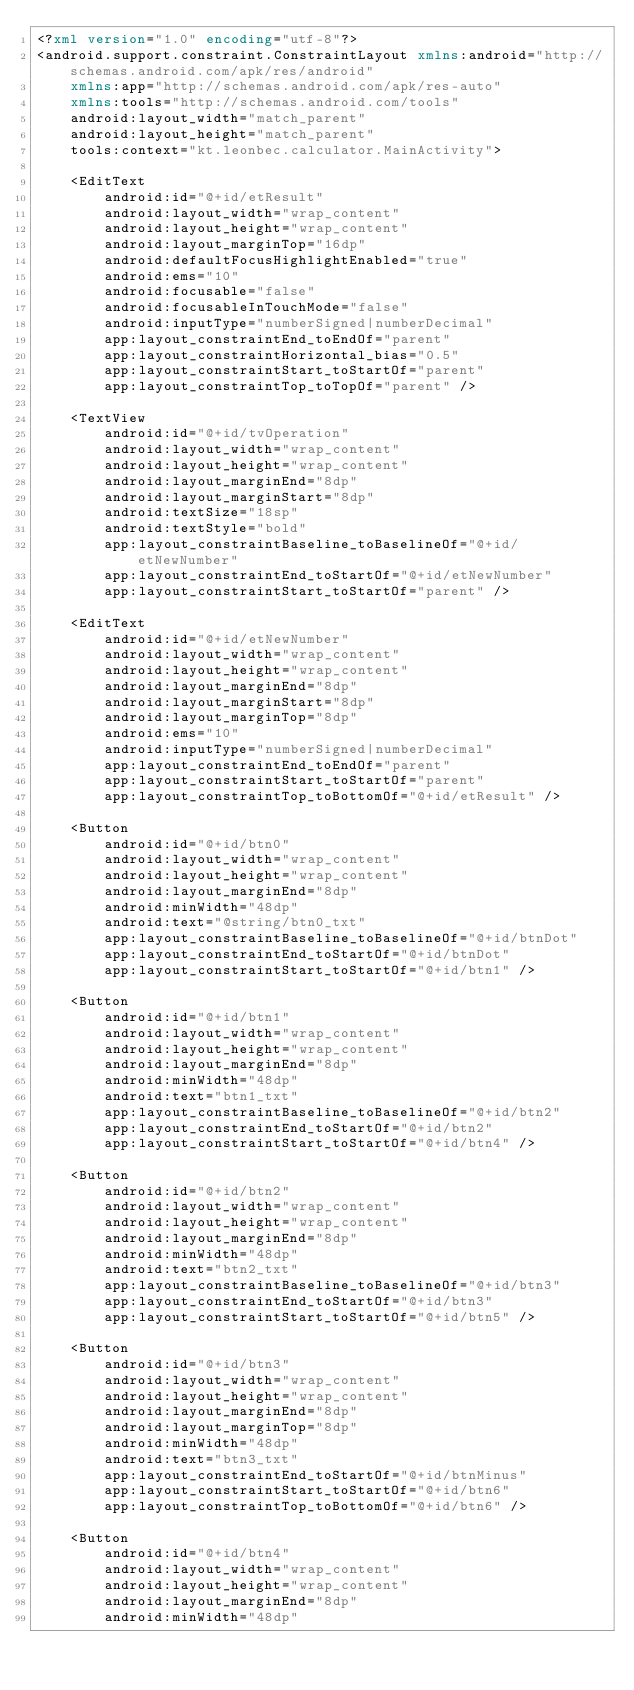Convert code to text. <code><loc_0><loc_0><loc_500><loc_500><_XML_><?xml version="1.0" encoding="utf-8"?>
<android.support.constraint.ConstraintLayout xmlns:android="http://schemas.android.com/apk/res/android"
    xmlns:app="http://schemas.android.com/apk/res-auto"
    xmlns:tools="http://schemas.android.com/tools"
    android:layout_width="match_parent"
    android:layout_height="match_parent"
    tools:context="kt.leonbec.calculator.MainActivity">

    <EditText
        android:id="@+id/etResult"
        android:layout_width="wrap_content"
        android:layout_height="wrap_content"
        android:layout_marginTop="16dp"
        android:defaultFocusHighlightEnabled="true"
        android:ems="10"
        android:focusable="false"
        android:focusableInTouchMode="false"
        android:inputType="numberSigned|numberDecimal"
        app:layout_constraintEnd_toEndOf="parent"
        app:layout_constraintHorizontal_bias="0.5"
        app:layout_constraintStart_toStartOf="parent"
        app:layout_constraintTop_toTopOf="parent" />

    <TextView
        android:id="@+id/tvOperation"
        android:layout_width="wrap_content"
        android:layout_height="wrap_content"
        android:layout_marginEnd="8dp"
        android:layout_marginStart="8dp"
        android:textSize="18sp"
        android:textStyle="bold"
        app:layout_constraintBaseline_toBaselineOf="@+id/etNewNumber"
        app:layout_constraintEnd_toStartOf="@+id/etNewNumber"
        app:layout_constraintStart_toStartOf="parent" />

    <EditText
        android:id="@+id/etNewNumber"
        android:layout_width="wrap_content"
        android:layout_height="wrap_content"
        android:layout_marginEnd="8dp"
        android:layout_marginStart="8dp"
        android:layout_marginTop="8dp"
        android:ems="10"
        android:inputType="numberSigned|numberDecimal"
        app:layout_constraintEnd_toEndOf="parent"
        app:layout_constraintStart_toStartOf="parent"
        app:layout_constraintTop_toBottomOf="@+id/etResult" />

    <Button
        android:id="@+id/btn0"
        android:layout_width="wrap_content"
        android:layout_height="wrap_content"
        android:layout_marginEnd="8dp"
        android:minWidth="48dp"
        android:text="@string/btn0_txt"
        app:layout_constraintBaseline_toBaselineOf="@+id/btnDot"
        app:layout_constraintEnd_toStartOf="@+id/btnDot"
        app:layout_constraintStart_toStartOf="@+id/btn1" />

    <Button
        android:id="@+id/btn1"
        android:layout_width="wrap_content"
        android:layout_height="wrap_content"
        android:layout_marginEnd="8dp"
        android:minWidth="48dp"
        android:text="btn1_txt"
        app:layout_constraintBaseline_toBaselineOf="@+id/btn2"
        app:layout_constraintEnd_toStartOf="@+id/btn2"
        app:layout_constraintStart_toStartOf="@+id/btn4" />

    <Button
        android:id="@+id/btn2"
        android:layout_width="wrap_content"
        android:layout_height="wrap_content"
        android:layout_marginEnd="8dp"
        android:minWidth="48dp"
        android:text="btn2_txt"
        app:layout_constraintBaseline_toBaselineOf="@+id/btn3"
        app:layout_constraintEnd_toStartOf="@+id/btn3"
        app:layout_constraintStart_toStartOf="@+id/btn5" />

    <Button
        android:id="@+id/btn3"
        android:layout_width="wrap_content"
        android:layout_height="wrap_content"
        android:layout_marginEnd="8dp"
        android:layout_marginTop="8dp"
        android:minWidth="48dp"
        android:text="btn3_txt"
        app:layout_constraintEnd_toStartOf="@+id/btnMinus"
        app:layout_constraintStart_toStartOf="@+id/btn6"
        app:layout_constraintTop_toBottomOf="@+id/btn6" />

    <Button
        android:id="@+id/btn4"
        android:layout_width="wrap_content"
        android:layout_height="wrap_content"
        android:layout_marginEnd="8dp"
        android:minWidth="48dp"</code> 